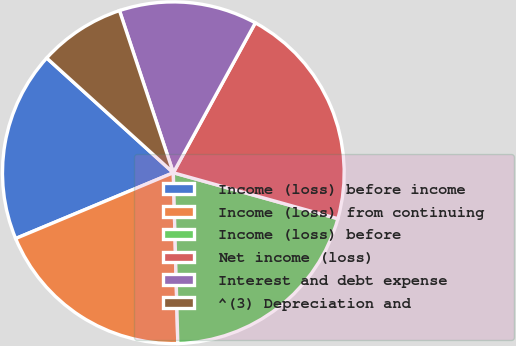Convert chart to OTSL. <chart><loc_0><loc_0><loc_500><loc_500><pie_chart><fcel>Income (loss) before income<fcel>Income (loss) from continuing<fcel>Income (loss) before<fcel>Net income (loss)<fcel>Interest and debt expense<fcel>^(3) Depreciation and<nl><fcel>18.01%<fcel>19.13%<fcel>20.25%<fcel>21.37%<fcel>13.07%<fcel>8.18%<nl></chart> 